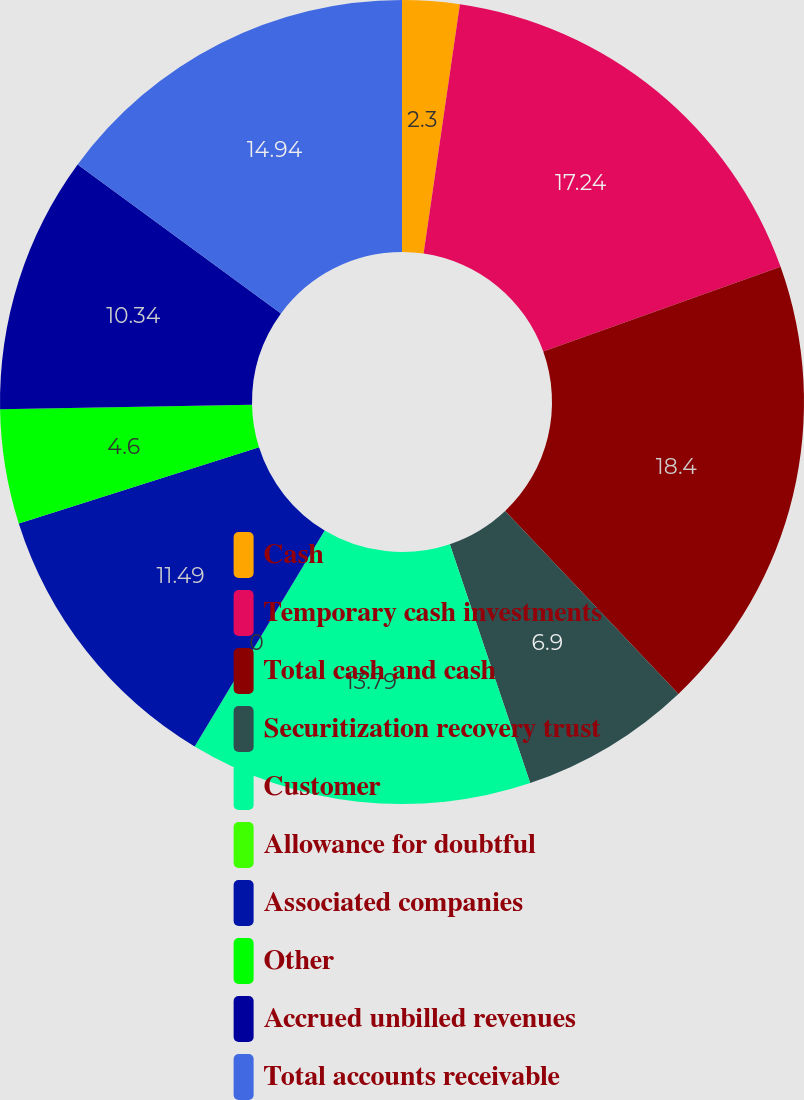Convert chart. <chart><loc_0><loc_0><loc_500><loc_500><pie_chart><fcel>Cash<fcel>Temporary cash investments<fcel>Total cash and cash<fcel>Securitization recovery trust<fcel>Customer<fcel>Allowance for doubtful<fcel>Associated companies<fcel>Other<fcel>Accrued unbilled revenues<fcel>Total accounts receivable<nl><fcel>2.3%<fcel>17.24%<fcel>18.39%<fcel>6.9%<fcel>13.79%<fcel>0.0%<fcel>11.49%<fcel>4.6%<fcel>10.34%<fcel>14.94%<nl></chart> 